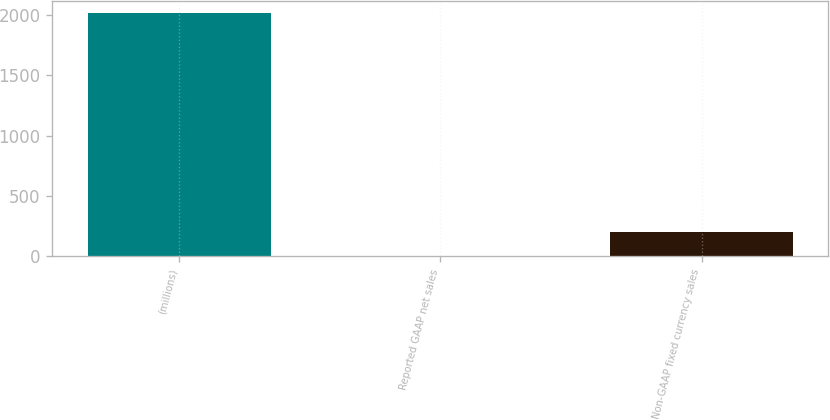Convert chart to OTSL. <chart><loc_0><loc_0><loc_500><loc_500><bar_chart><fcel>(millions)<fcel>Reported GAAP net sales<fcel>Non-GAAP fixed currency sales<nl><fcel>2016<fcel>3<fcel>204.3<nl></chart> 